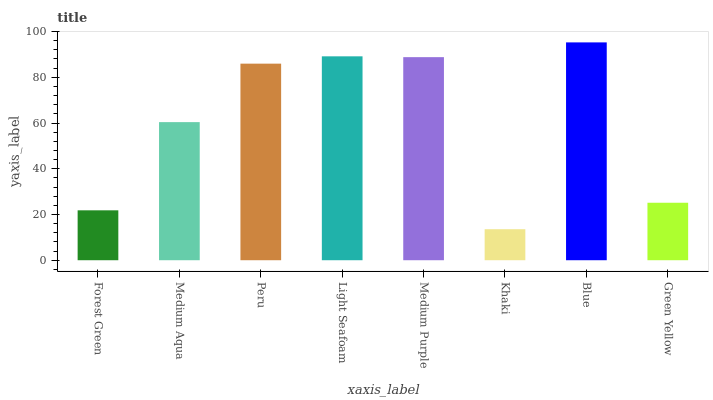Is Khaki the minimum?
Answer yes or no. Yes. Is Blue the maximum?
Answer yes or no. Yes. Is Medium Aqua the minimum?
Answer yes or no. No. Is Medium Aqua the maximum?
Answer yes or no. No. Is Medium Aqua greater than Forest Green?
Answer yes or no. Yes. Is Forest Green less than Medium Aqua?
Answer yes or no. Yes. Is Forest Green greater than Medium Aqua?
Answer yes or no. No. Is Medium Aqua less than Forest Green?
Answer yes or no. No. Is Peru the high median?
Answer yes or no. Yes. Is Medium Aqua the low median?
Answer yes or no. Yes. Is Forest Green the high median?
Answer yes or no. No. Is Blue the low median?
Answer yes or no. No. 